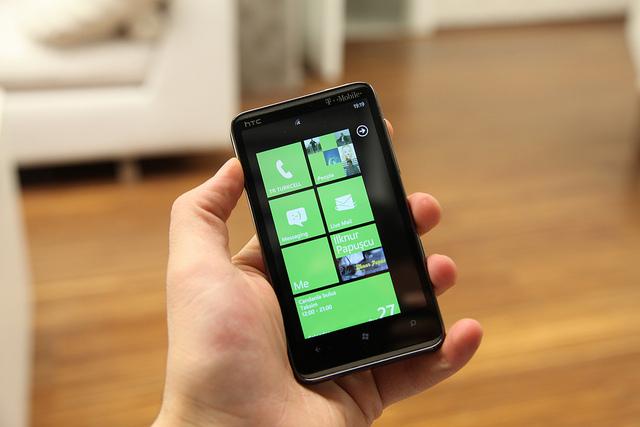What operating system does this phone have?
Short answer required. Windows. Does the floor have carpet?
Be succinct. No. Does this phone have a keyboard on it?
Write a very short answer. No. How is the furniture on the top left upholstered?
Answer briefly. Leather. What it the phone being used for?
Be succinct. Texting. What is this person doing?
Keep it brief. Phone. 